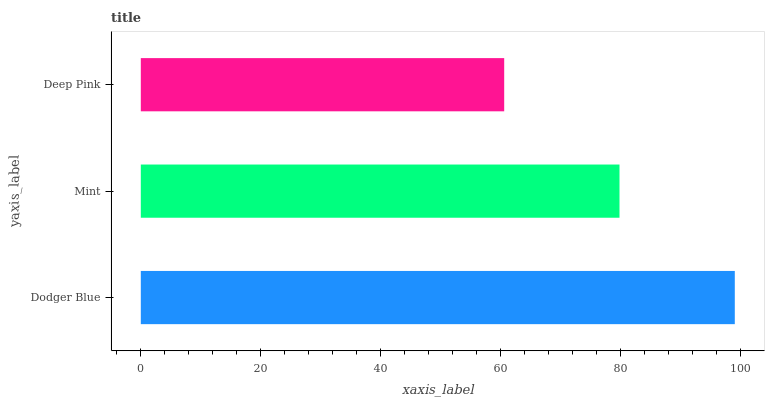Is Deep Pink the minimum?
Answer yes or no. Yes. Is Dodger Blue the maximum?
Answer yes or no. Yes. Is Mint the minimum?
Answer yes or no. No. Is Mint the maximum?
Answer yes or no. No. Is Dodger Blue greater than Mint?
Answer yes or no. Yes. Is Mint less than Dodger Blue?
Answer yes or no. Yes. Is Mint greater than Dodger Blue?
Answer yes or no. No. Is Dodger Blue less than Mint?
Answer yes or no. No. Is Mint the high median?
Answer yes or no. Yes. Is Mint the low median?
Answer yes or no. Yes. Is Deep Pink the high median?
Answer yes or no. No. Is Dodger Blue the low median?
Answer yes or no. No. 